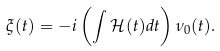Convert formula to latex. <formula><loc_0><loc_0><loc_500><loc_500>\xi ( t ) = - i \left ( \int \mathcal { H } ( t ) d t \right ) \nu _ { 0 } ( t ) .</formula> 